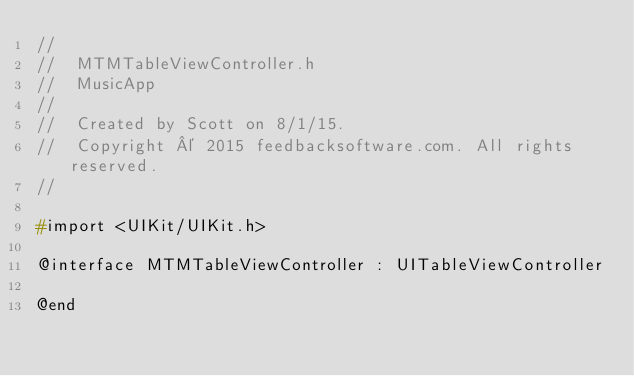Convert code to text. <code><loc_0><loc_0><loc_500><loc_500><_C_>//
//  MTMTableViewController.h
//  MusicApp
//
//  Created by Scott on 8/1/15.
//  Copyright © 2015 feedbacksoftware.com. All rights reserved.
//

#import <UIKit/UIKit.h>

@interface MTMTableViewController : UITableViewController

@end
</code> 